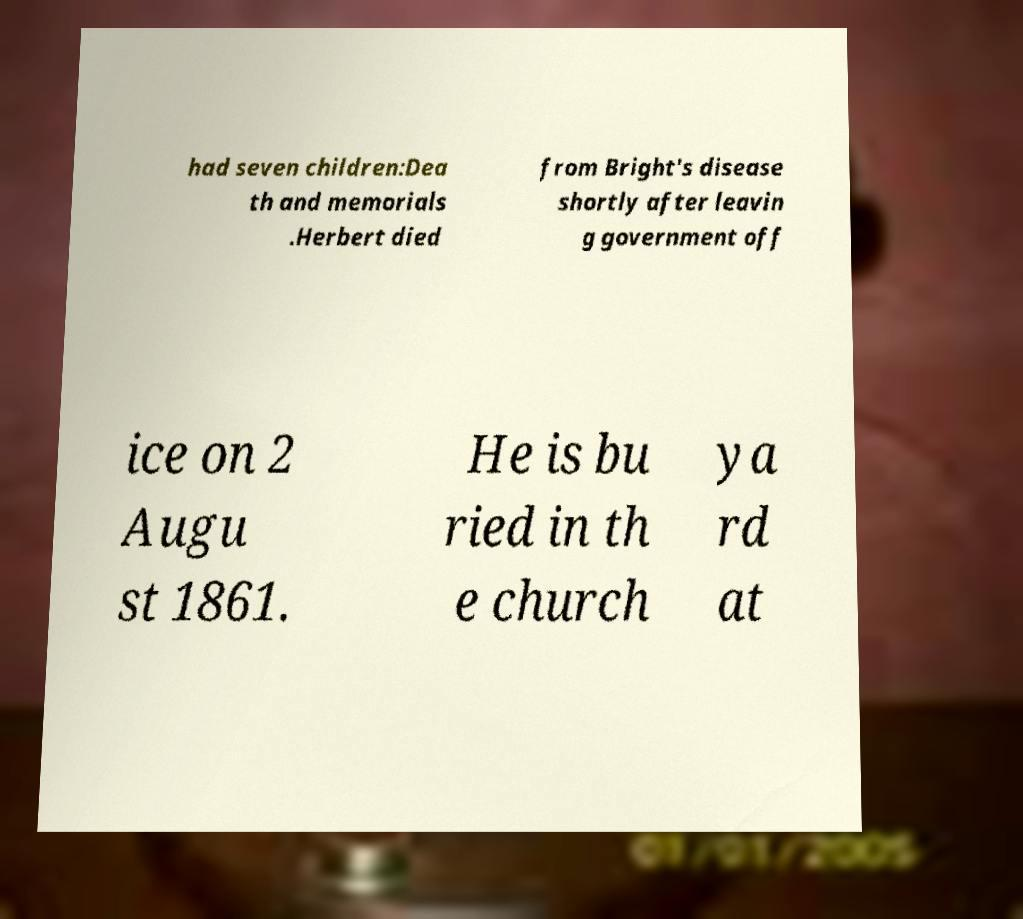Can you read and provide the text displayed in the image?This photo seems to have some interesting text. Can you extract and type it out for me? had seven children:Dea th and memorials .Herbert died from Bright's disease shortly after leavin g government off ice on 2 Augu st 1861. He is bu ried in th e church ya rd at 